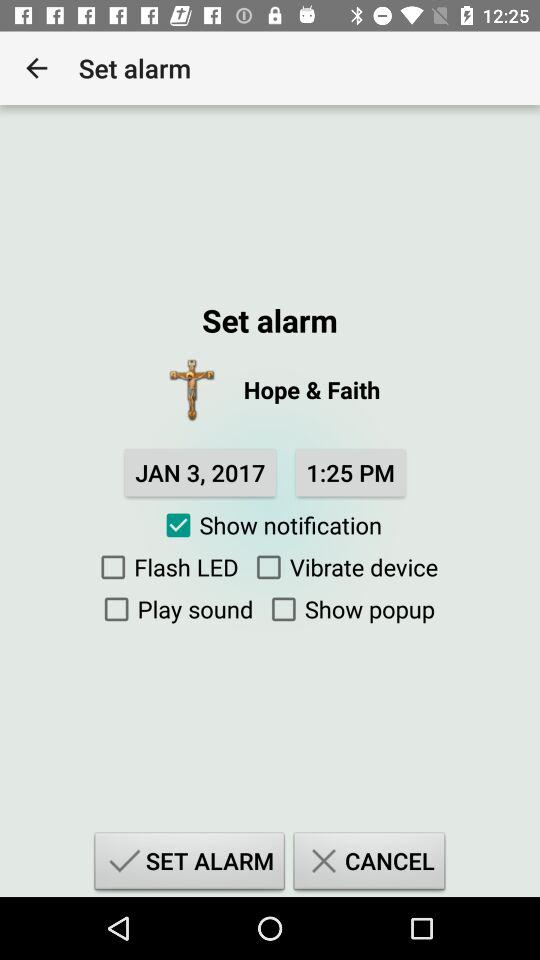What is the given date? The given date is January 3, 2017. 